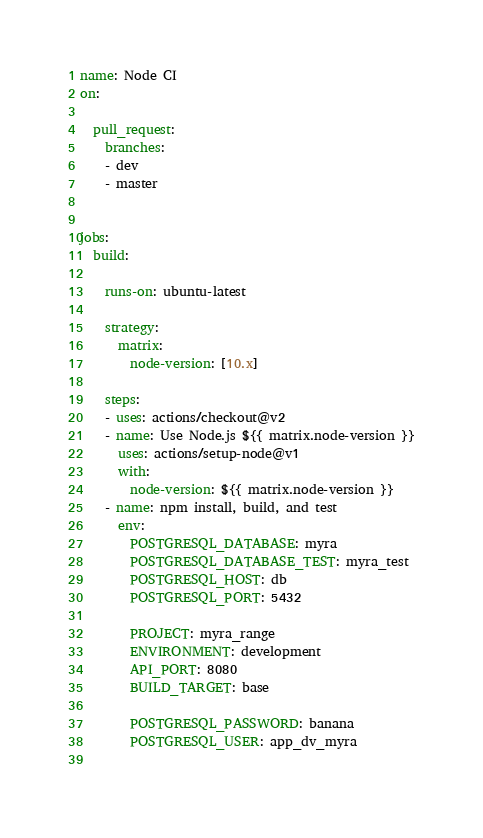Convert code to text. <code><loc_0><loc_0><loc_500><loc_500><_YAML_>name: Node CI
on:

  pull_request:
    branches:
    - dev
    - master


jobs:
  build:

    runs-on: ubuntu-latest

    strategy:
      matrix:
        node-version: [10.x] 

    steps:
    - uses: actions/checkout@v2
    - name: Use Node.js ${{ matrix.node-version }}
      uses: actions/setup-node@v1
      with:
        node-version: ${{ matrix.node-version }}
    - name: npm install, build, and test
      env:
        POSTGRESQL_DATABASE: myra
        POSTGRESQL_DATABASE_TEST: myra_test
        POSTGRESQL_HOST: db
        POSTGRESQL_PORT: 5432

        PROJECT: myra_range
        ENVIRONMENT: development
        API_PORT: 8080
        BUILD_TARGET: base

        POSTGRESQL_PASSWORD: banana
        POSTGRESQL_USER: app_dv_myra
      </code> 